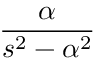Convert formula to latex. <formula><loc_0><loc_0><loc_500><loc_500>\frac { \alpha } { s ^ { 2 } - \alpha ^ { 2 } }</formula> 